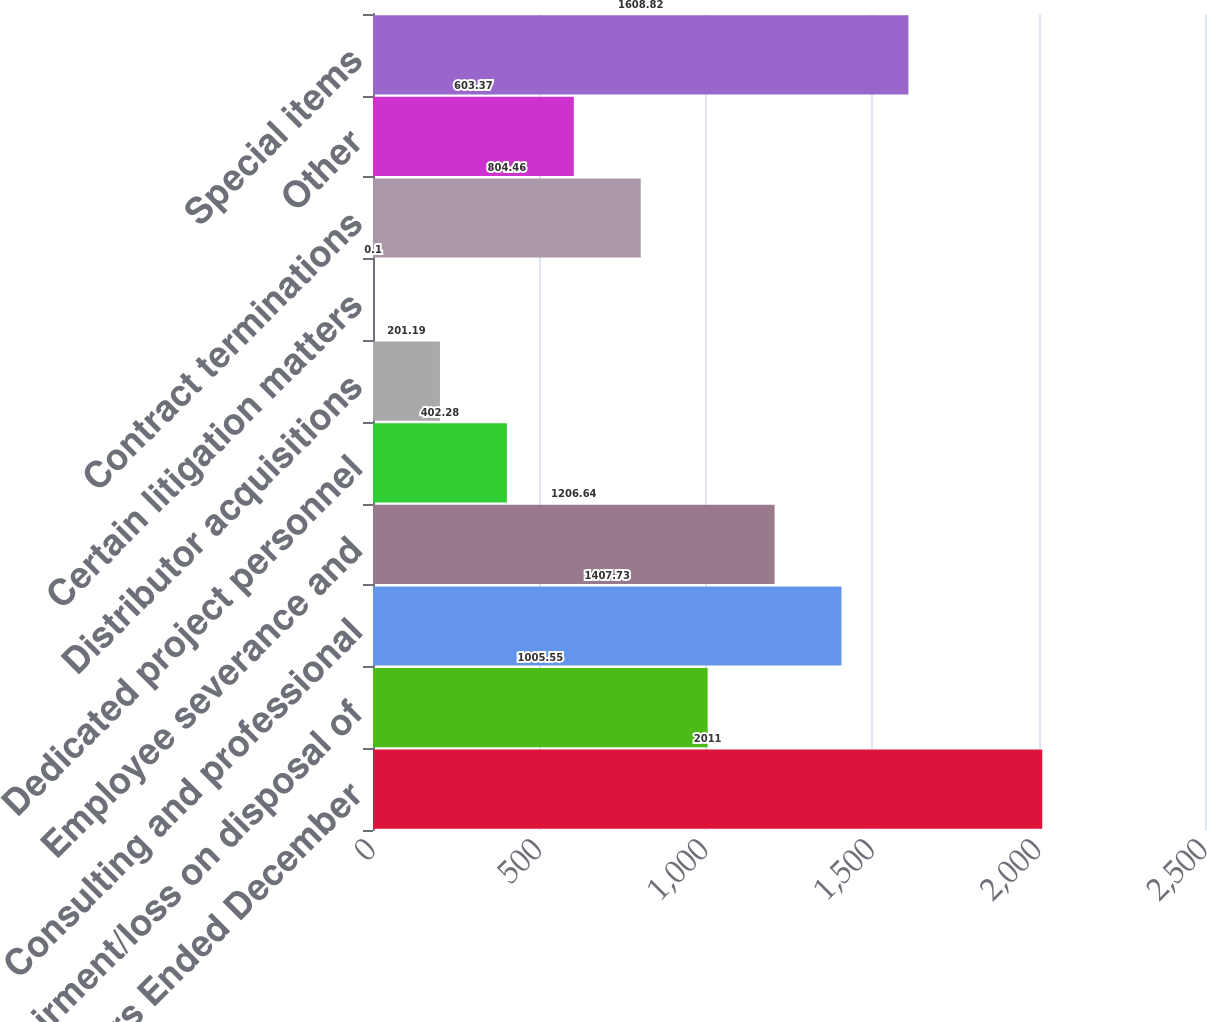Convert chart to OTSL. <chart><loc_0><loc_0><loc_500><loc_500><bar_chart><fcel>For the Years Ended December<fcel>Impairment/loss on disposal of<fcel>Consulting and professional<fcel>Employee severance and<fcel>Dedicated project personnel<fcel>Distributor acquisitions<fcel>Certain litigation matters<fcel>Contract terminations<fcel>Other<fcel>Special items<nl><fcel>2011<fcel>1005.55<fcel>1407.73<fcel>1206.64<fcel>402.28<fcel>201.19<fcel>0.1<fcel>804.46<fcel>603.37<fcel>1608.82<nl></chart> 